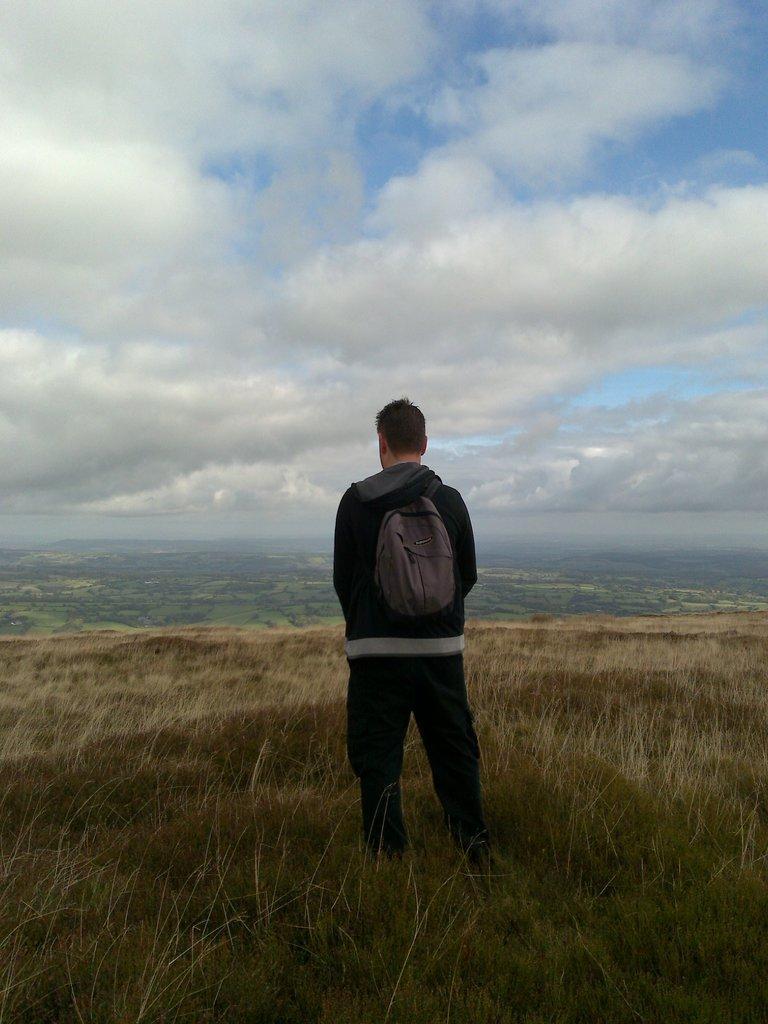Can you describe this image briefly? In this image we can see a person wearing a jacket and a bag is standing on the ground. In the background, we can see the cloudy sky. 